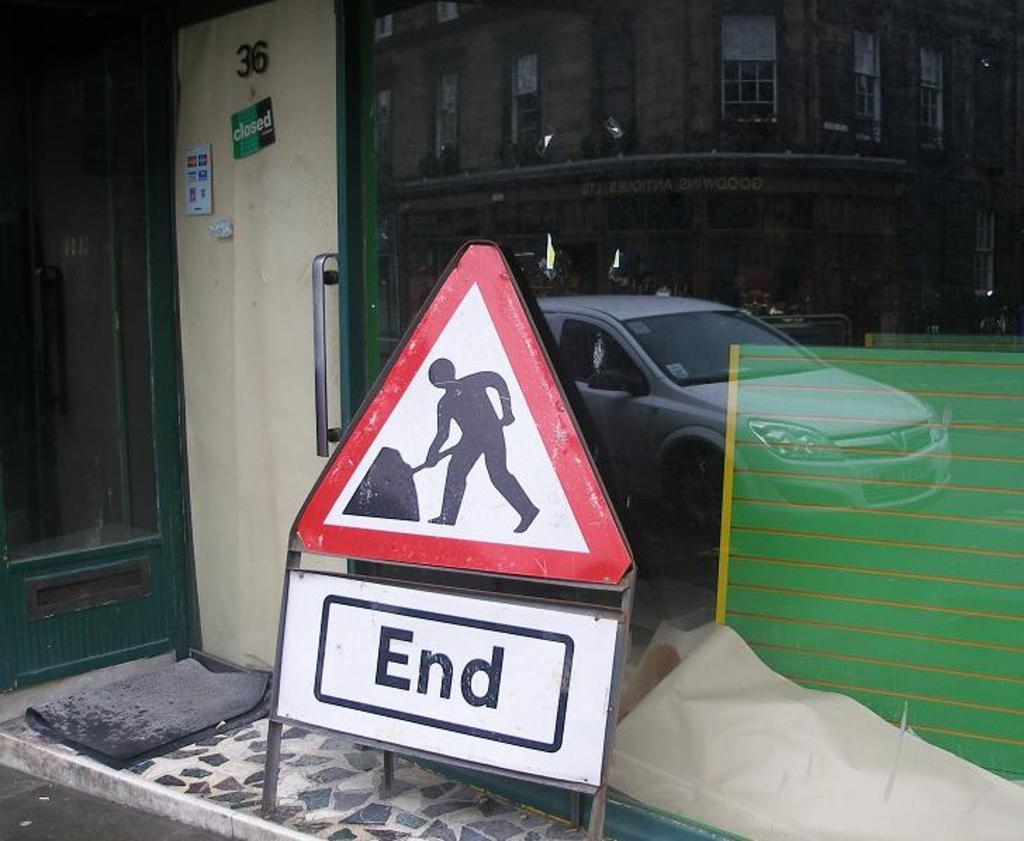<image>
Summarize the visual content of the image. A sign with a red triangle on it shows a person digging with a sign below it that says, "End". 